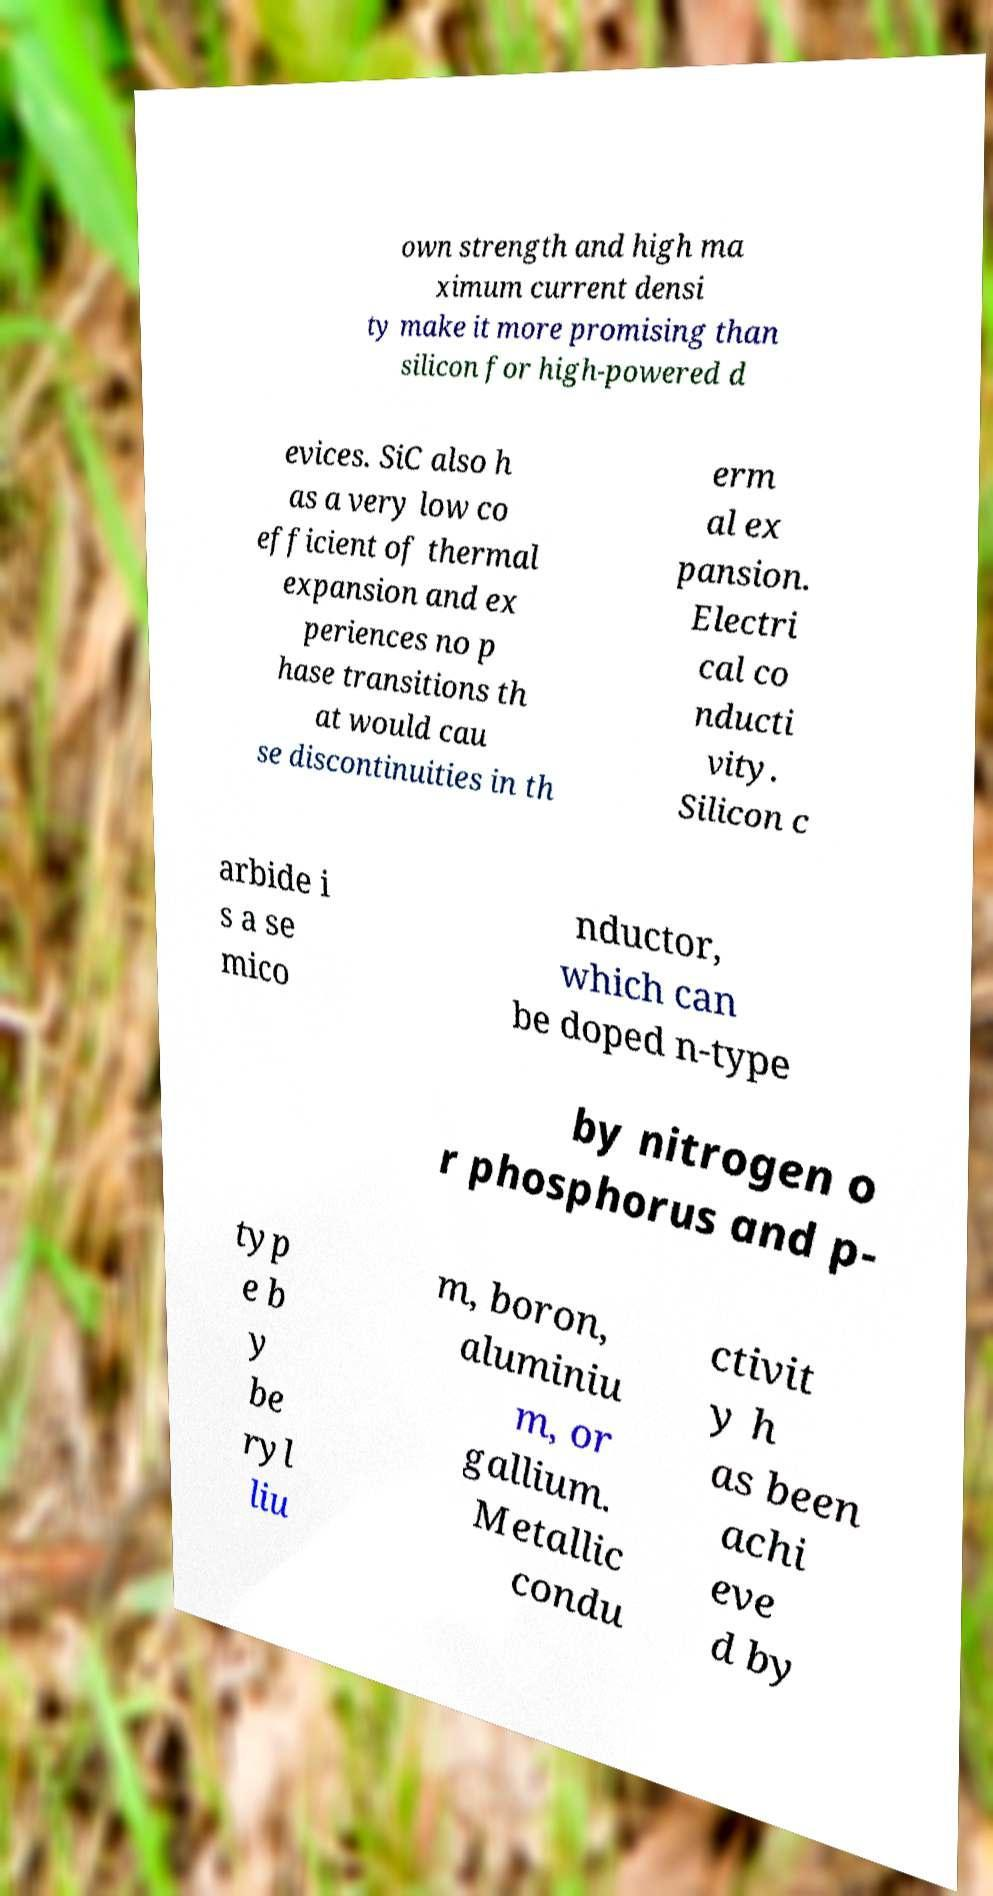There's text embedded in this image that I need extracted. Can you transcribe it verbatim? own strength and high ma ximum current densi ty make it more promising than silicon for high-powered d evices. SiC also h as a very low co efficient of thermal expansion and ex periences no p hase transitions th at would cau se discontinuities in th erm al ex pansion. Electri cal co nducti vity. Silicon c arbide i s a se mico nductor, which can be doped n-type by nitrogen o r phosphorus and p- typ e b y be ryl liu m, boron, aluminiu m, or gallium. Metallic condu ctivit y h as been achi eve d by 